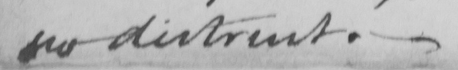Transcribe the text shown in this historical manuscript line. no distrust .  _ 